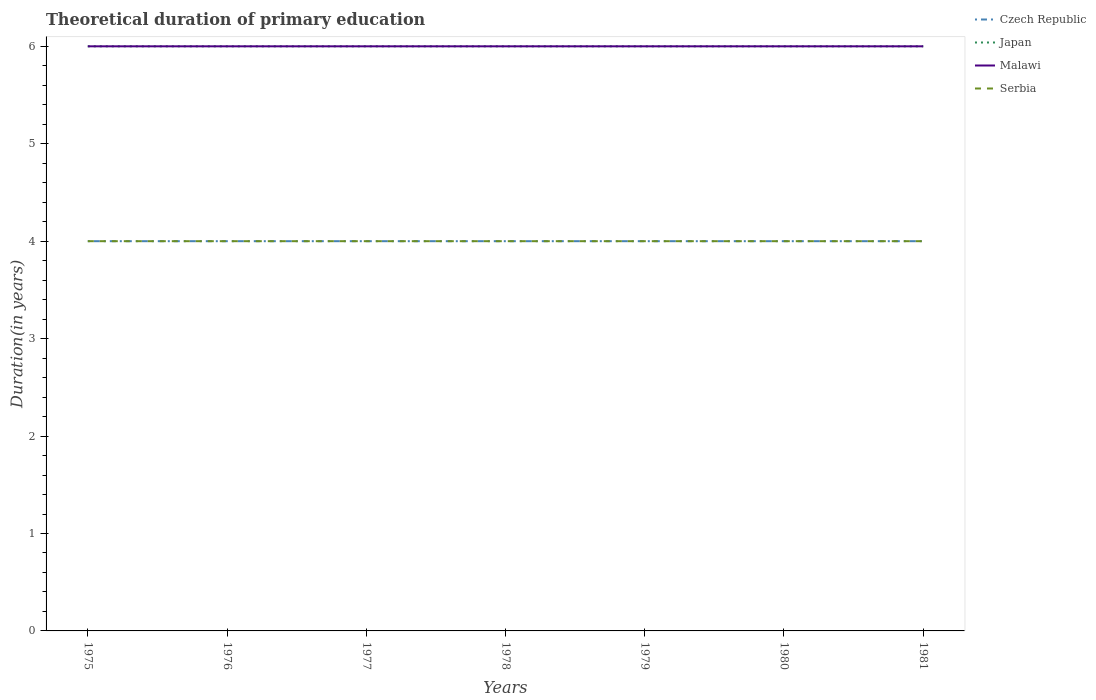Does the line corresponding to Japan intersect with the line corresponding to Malawi?
Offer a very short reply. Yes. Across all years, what is the maximum total theoretical duration of primary education in Czech Republic?
Provide a succinct answer. 4. In which year was the total theoretical duration of primary education in Malawi maximum?
Make the answer very short. 1975. What is the total total theoretical duration of primary education in Serbia in the graph?
Offer a very short reply. 0. Is the total theoretical duration of primary education in Japan strictly greater than the total theoretical duration of primary education in Serbia over the years?
Offer a very short reply. No. How many years are there in the graph?
Make the answer very short. 7. Are the values on the major ticks of Y-axis written in scientific E-notation?
Your answer should be compact. No. Does the graph contain any zero values?
Ensure brevity in your answer.  No. Does the graph contain grids?
Ensure brevity in your answer.  No. What is the title of the graph?
Provide a short and direct response. Theoretical duration of primary education. What is the label or title of the X-axis?
Your response must be concise. Years. What is the label or title of the Y-axis?
Your response must be concise. Duration(in years). What is the Duration(in years) in Malawi in 1975?
Provide a succinct answer. 6. What is the Duration(in years) in Serbia in 1975?
Give a very brief answer. 4. What is the Duration(in years) in Czech Republic in 1977?
Your answer should be very brief. 4. What is the Duration(in years) in Malawi in 1977?
Provide a succinct answer. 6. What is the Duration(in years) of Serbia in 1977?
Your response must be concise. 4. What is the Duration(in years) of Czech Republic in 1978?
Offer a terse response. 4. What is the Duration(in years) in Serbia in 1979?
Give a very brief answer. 4. What is the Duration(in years) in Czech Republic in 1980?
Your answer should be compact. 4. What is the Duration(in years) of Japan in 1980?
Your response must be concise. 6. What is the Duration(in years) of Malawi in 1980?
Provide a short and direct response. 6. What is the Duration(in years) of Czech Republic in 1981?
Your answer should be compact. 4. Across all years, what is the maximum Duration(in years) in Czech Republic?
Your response must be concise. 4. Across all years, what is the maximum Duration(in years) of Japan?
Keep it short and to the point. 6. Across all years, what is the maximum Duration(in years) in Malawi?
Ensure brevity in your answer.  6. Across all years, what is the maximum Duration(in years) of Serbia?
Offer a very short reply. 4. Across all years, what is the minimum Duration(in years) in Czech Republic?
Keep it short and to the point. 4. Across all years, what is the minimum Duration(in years) in Japan?
Your answer should be very brief. 6. What is the total Duration(in years) in Malawi in the graph?
Make the answer very short. 42. What is the difference between the Duration(in years) of Japan in 1975 and that in 1977?
Provide a succinct answer. 0. What is the difference between the Duration(in years) in Malawi in 1975 and that in 1977?
Make the answer very short. 0. What is the difference between the Duration(in years) in Serbia in 1975 and that in 1977?
Keep it short and to the point. 0. What is the difference between the Duration(in years) of Japan in 1975 and that in 1978?
Make the answer very short. 0. What is the difference between the Duration(in years) of Serbia in 1975 and that in 1978?
Your response must be concise. 0. What is the difference between the Duration(in years) of Czech Republic in 1975 and that in 1979?
Your answer should be very brief. 0. What is the difference between the Duration(in years) in Japan in 1975 and that in 1979?
Your answer should be very brief. 0. What is the difference between the Duration(in years) of Malawi in 1975 and that in 1979?
Your answer should be compact. 0. What is the difference between the Duration(in years) in Malawi in 1975 and that in 1980?
Give a very brief answer. 0. What is the difference between the Duration(in years) of Japan in 1975 and that in 1981?
Ensure brevity in your answer.  0. What is the difference between the Duration(in years) in Malawi in 1975 and that in 1981?
Your answer should be very brief. 0. What is the difference between the Duration(in years) in Japan in 1976 and that in 1977?
Ensure brevity in your answer.  0. What is the difference between the Duration(in years) of Malawi in 1976 and that in 1977?
Provide a succinct answer. 0. What is the difference between the Duration(in years) in Serbia in 1976 and that in 1977?
Offer a terse response. 0. What is the difference between the Duration(in years) of Czech Republic in 1976 and that in 1978?
Offer a very short reply. 0. What is the difference between the Duration(in years) of Japan in 1976 and that in 1978?
Your response must be concise. 0. What is the difference between the Duration(in years) of Malawi in 1976 and that in 1978?
Make the answer very short. 0. What is the difference between the Duration(in years) in Czech Republic in 1976 and that in 1979?
Your answer should be compact. 0. What is the difference between the Duration(in years) of Malawi in 1976 and that in 1979?
Keep it short and to the point. 0. What is the difference between the Duration(in years) of Serbia in 1976 and that in 1979?
Give a very brief answer. 0. What is the difference between the Duration(in years) of Serbia in 1976 and that in 1980?
Make the answer very short. 0. What is the difference between the Duration(in years) of Japan in 1976 and that in 1981?
Give a very brief answer. 0. What is the difference between the Duration(in years) of Czech Republic in 1977 and that in 1978?
Your response must be concise. 0. What is the difference between the Duration(in years) in Czech Republic in 1977 and that in 1979?
Provide a succinct answer. 0. What is the difference between the Duration(in years) in Serbia in 1977 and that in 1979?
Provide a short and direct response. 0. What is the difference between the Duration(in years) of Czech Republic in 1977 and that in 1980?
Ensure brevity in your answer.  0. What is the difference between the Duration(in years) in Serbia in 1977 and that in 1980?
Provide a short and direct response. 0. What is the difference between the Duration(in years) in Czech Republic in 1977 and that in 1981?
Provide a short and direct response. 0. What is the difference between the Duration(in years) in Japan in 1977 and that in 1981?
Provide a short and direct response. 0. What is the difference between the Duration(in years) of Malawi in 1977 and that in 1981?
Give a very brief answer. 0. What is the difference between the Duration(in years) of Serbia in 1977 and that in 1981?
Keep it short and to the point. 0. What is the difference between the Duration(in years) in Czech Republic in 1978 and that in 1979?
Make the answer very short. 0. What is the difference between the Duration(in years) in Japan in 1978 and that in 1979?
Keep it short and to the point. 0. What is the difference between the Duration(in years) of Malawi in 1978 and that in 1979?
Your answer should be very brief. 0. What is the difference between the Duration(in years) of Czech Republic in 1978 and that in 1980?
Keep it short and to the point. 0. What is the difference between the Duration(in years) of Malawi in 1978 and that in 1981?
Ensure brevity in your answer.  0. What is the difference between the Duration(in years) in Malawi in 1979 and that in 1980?
Give a very brief answer. 0. What is the difference between the Duration(in years) in Japan in 1979 and that in 1981?
Offer a very short reply. 0. What is the difference between the Duration(in years) in Malawi in 1979 and that in 1981?
Your response must be concise. 0. What is the difference between the Duration(in years) of Serbia in 1979 and that in 1981?
Offer a terse response. 0. What is the difference between the Duration(in years) in Czech Republic in 1980 and that in 1981?
Provide a short and direct response. 0. What is the difference between the Duration(in years) in Japan in 1980 and that in 1981?
Your answer should be compact. 0. What is the difference between the Duration(in years) in Malawi in 1980 and that in 1981?
Give a very brief answer. 0. What is the difference between the Duration(in years) in Serbia in 1980 and that in 1981?
Your answer should be very brief. 0. What is the difference between the Duration(in years) in Czech Republic in 1975 and the Duration(in years) in Serbia in 1976?
Your answer should be compact. 0. What is the difference between the Duration(in years) of Japan in 1975 and the Duration(in years) of Malawi in 1976?
Offer a terse response. 0. What is the difference between the Duration(in years) of Malawi in 1975 and the Duration(in years) of Serbia in 1976?
Your response must be concise. 2. What is the difference between the Duration(in years) of Czech Republic in 1975 and the Duration(in years) of Japan in 1977?
Your answer should be very brief. -2. What is the difference between the Duration(in years) in Japan in 1975 and the Duration(in years) in Malawi in 1977?
Offer a terse response. 0. What is the difference between the Duration(in years) of Japan in 1975 and the Duration(in years) of Serbia in 1977?
Ensure brevity in your answer.  2. What is the difference between the Duration(in years) of Malawi in 1975 and the Duration(in years) of Serbia in 1977?
Your answer should be compact. 2. What is the difference between the Duration(in years) of Czech Republic in 1975 and the Duration(in years) of Japan in 1978?
Keep it short and to the point. -2. What is the difference between the Duration(in years) of Czech Republic in 1975 and the Duration(in years) of Malawi in 1978?
Your response must be concise. -2. What is the difference between the Duration(in years) in Czech Republic in 1975 and the Duration(in years) in Serbia in 1978?
Your answer should be very brief. 0. What is the difference between the Duration(in years) of Czech Republic in 1975 and the Duration(in years) of Malawi in 1979?
Make the answer very short. -2. What is the difference between the Duration(in years) in Czech Republic in 1975 and the Duration(in years) in Serbia in 1979?
Make the answer very short. 0. What is the difference between the Duration(in years) in Japan in 1975 and the Duration(in years) in Malawi in 1979?
Provide a short and direct response. 0. What is the difference between the Duration(in years) of Japan in 1975 and the Duration(in years) of Serbia in 1979?
Your response must be concise. 2. What is the difference between the Duration(in years) in Malawi in 1975 and the Duration(in years) in Serbia in 1979?
Your answer should be very brief. 2. What is the difference between the Duration(in years) of Czech Republic in 1975 and the Duration(in years) of Japan in 1980?
Offer a very short reply. -2. What is the difference between the Duration(in years) in Czech Republic in 1975 and the Duration(in years) in Malawi in 1980?
Offer a very short reply. -2. What is the difference between the Duration(in years) of Japan in 1975 and the Duration(in years) of Malawi in 1980?
Offer a very short reply. 0. What is the difference between the Duration(in years) of Japan in 1975 and the Duration(in years) of Serbia in 1980?
Your answer should be compact. 2. What is the difference between the Duration(in years) in Malawi in 1975 and the Duration(in years) in Serbia in 1980?
Your response must be concise. 2. What is the difference between the Duration(in years) of Czech Republic in 1975 and the Duration(in years) of Malawi in 1981?
Keep it short and to the point. -2. What is the difference between the Duration(in years) in Japan in 1976 and the Duration(in years) in Serbia in 1977?
Ensure brevity in your answer.  2. What is the difference between the Duration(in years) of Malawi in 1976 and the Duration(in years) of Serbia in 1977?
Offer a terse response. 2. What is the difference between the Duration(in years) of Czech Republic in 1976 and the Duration(in years) of Japan in 1978?
Provide a short and direct response. -2. What is the difference between the Duration(in years) of Japan in 1976 and the Duration(in years) of Malawi in 1978?
Provide a short and direct response. 0. What is the difference between the Duration(in years) of Japan in 1976 and the Duration(in years) of Serbia in 1978?
Your answer should be very brief. 2. What is the difference between the Duration(in years) of Czech Republic in 1976 and the Duration(in years) of Japan in 1979?
Keep it short and to the point. -2. What is the difference between the Duration(in years) in Japan in 1976 and the Duration(in years) in Malawi in 1979?
Ensure brevity in your answer.  0. What is the difference between the Duration(in years) in Japan in 1976 and the Duration(in years) in Serbia in 1979?
Your answer should be very brief. 2. What is the difference between the Duration(in years) of Czech Republic in 1976 and the Duration(in years) of Malawi in 1980?
Ensure brevity in your answer.  -2. What is the difference between the Duration(in years) in Czech Republic in 1976 and the Duration(in years) in Serbia in 1980?
Keep it short and to the point. 0. What is the difference between the Duration(in years) in Japan in 1976 and the Duration(in years) in Malawi in 1980?
Give a very brief answer. 0. What is the difference between the Duration(in years) of Czech Republic in 1976 and the Duration(in years) of Japan in 1981?
Offer a very short reply. -2. What is the difference between the Duration(in years) in Japan in 1976 and the Duration(in years) in Malawi in 1981?
Your answer should be very brief. 0. What is the difference between the Duration(in years) of Malawi in 1976 and the Duration(in years) of Serbia in 1981?
Your answer should be very brief. 2. What is the difference between the Duration(in years) in Czech Republic in 1977 and the Duration(in years) in Japan in 1978?
Your answer should be compact. -2. What is the difference between the Duration(in years) of Czech Republic in 1977 and the Duration(in years) of Serbia in 1978?
Your answer should be very brief. 0. What is the difference between the Duration(in years) of Czech Republic in 1977 and the Duration(in years) of Malawi in 1979?
Your answer should be very brief. -2. What is the difference between the Duration(in years) of Czech Republic in 1977 and the Duration(in years) of Serbia in 1979?
Your answer should be very brief. 0. What is the difference between the Duration(in years) in Czech Republic in 1977 and the Duration(in years) in Japan in 1980?
Make the answer very short. -2. What is the difference between the Duration(in years) in Czech Republic in 1977 and the Duration(in years) in Malawi in 1980?
Offer a terse response. -2. What is the difference between the Duration(in years) of Malawi in 1977 and the Duration(in years) of Serbia in 1980?
Keep it short and to the point. 2. What is the difference between the Duration(in years) in Czech Republic in 1977 and the Duration(in years) in Malawi in 1981?
Offer a terse response. -2. What is the difference between the Duration(in years) of Czech Republic in 1977 and the Duration(in years) of Serbia in 1981?
Give a very brief answer. 0. What is the difference between the Duration(in years) in Japan in 1977 and the Duration(in years) in Serbia in 1981?
Offer a very short reply. 2. What is the difference between the Duration(in years) of Czech Republic in 1978 and the Duration(in years) of Japan in 1979?
Your answer should be very brief. -2. What is the difference between the Duration(in years) in Malawi in 1978 and the Duration(in years) in Serbia in 1979?
Your response must be concise. 2. What is the difference between the Duration(in years) in Japan in 1978 and the Duration(in years) in Malawi in 1980?
Your answer should be very brief. 0. What is the difference between the Duration(in years) of Malawi in 1978 and the Duration(in years) of Serbia in 1980?
Your response must be concise. 2. What is the difference between the Duration(in years) of Czech Republic in 1978 and the Duration(in years) of Japan in 1981?
Provide a short and direct response. -2. What is the difference between the Duration(in years) of Czech Republic in 1979 and the Duration(in years) of Malawi in 1980?
Provide a succinct answer. -2. What is the difference between the Duration(in years) of Czech Republic in 1979 and the Duration(in years) of Serbia in 1980?
Make the answer very short. 0. What is the difference between the Duration(in years) of Japan in 1979 and the Duration(in years) of Malawi in 1980?
Keep it short and to the point. 0. What is the difference between the Duration(in years) in Czech Republic in 1979 and the Duration(in years) in Japan in 1981?
Your answer should be very brief. -2. What is the difference between the Duration(in years) in Czech Republic in 1979 and the Duration(in years) in Serbia in 1981?
Provide a succinct answer. 0. What is the difference between the Duration(in years) of Japan in 1979 and the Duration(in years) of Serbia in 1981?
Ensure brevity in your answer.  2. What is the difference between the Duration(in years) in Malawi in 1979 and the Duration(in years) in Serbia in 1981?
Offer a terse response. 2. What is the difference between the Duration(in years) of Japan in 1980 and the Duration(in years) of Malawi in 1981?
Keep it short and to the point. 0. What is the average Duration(in years) of Japan per year?
Make the answer very short. 6. What is the average Duration(in years) in Malawi per year?
Your response must be concise. 6. In the year 1975, what is the difference between the Duration(in years) of Czech Republic and Duration(in years) of Japan?
Ensure brevity in your answer.  -2. In the year 1975, what is the difference between the Duration(in years) in Czech Republic and Duration(in years) in Malawi?
Your answer should be very brief. -2. In the year 1975, what is the difference between the Duration(in years) in Japan and Duration(in years) in Malawi?
Give a very brief answer. 0. In the year 1975, what is the difference between the Duration(in years) in Japan and Duration(in years) in Serbia?
Provide a succinct answer. 2. In the year 1976, what is the difference between the Duration(in years) of Czech Republic and Duration(in years) of Japan?
Give a very brief answer. -2. In the year 1976, what is the difference between the Duration(in years) in Japan and Duration(in years) in Serbia?
Your response must be concise. 2. In the year 1977, what is the difference between the Duration(in years) of Czech Republic and Duration(in years) of Japan?
Offer a terse response. -2. In the year 1977, what is the difference between the Duration(in years) of Czech Republic and Duration(in years) of Malawi?
Offer a very short reply. -2. In the year 1977, what is the difference between the Duration(in years) in Czech Republic and Duration(in years) in Serbia?
Your answer should be compact. 0. In the year 1978, what is the difference between the Duration(in years) of Czech Republic and Duration(in years) of Japan?
Offer a very short reply. -2. In the year 1978, what is the difference between the Duration(in years) of Czech Republic and Duration(in years) of Malawi?
Offer a very short reply. -2. In the year 1978, what is the difference between the Duration(in years) in Japan and Duration(in years) in Serbia?
Keep it short and to the point. 2. In the year 1978, what is the difference between the Duration(in years) of Malawi and Duration(in years) of Serbia?
Offer a very short reply. 2. In the year 1979, what is the difference between the Duration(in years) of Czech Republic and Duration(in years) of Japan?
Give a very brief answer. -2. In the year 1979, what is the difference between the Duration(in years) of Japan and Duration(in years) of Serbia?
Ensure brevity in your answer.  2. In the year 1980, what is the difference between the Duration(in years) in Czech Republic and Duration(in years) in Serbia?
Your answer should be compact. 0. In the year 1980, what is the difference between the Duration(in years) in Malawi and Duration(in years) in Serbia?
Your answer should be compact. 2. In the year 1981, what is the difference between the Duration(in years) in Japan and Duration(in years) in Malawi?
Provide a succinct answer. 0. In the year 1981, what is the difference between the Duration(in years) in Malawi and Duration(in years) in Serbia?
Keep it short and to the point. 2. What is the ratio of the Duration(in years) of Malawi in 1975 to that in 1976?
Provide a short and direct response. 1. What is the ratio of the Duration(in years) of Serbia in 1975 to that in 1976?
Ensure brevity in your answer.  1. What is the ratio of the Duration(in years) in Malawi in 1975 to that in 1977?
Provide a short and direct response. 1. What is the ratio of the Duration(in years) in Japan in 1975 to that in 1978?
Make the answer very short. 1. What is the ratio of the Duration(in years) in Malawi in 1975 to that in 1978?
Your answer should be compact. 1. What is the ratio of the Duration(in years) in Japan in 1975 to that in 1980?
Your response must be concise. 1. What is the ratio of the Duration(in years) of Malawi in 1975 to that in 1980?
Your answer should be compact. 1. What is the ratio of the Duration(in years) of Czech Republic in 1976 to that in 1977?
Give a very brief answer. 1. What is the ratio of the Duration(in years) in Malawi in 1976 to that in 1977?
Your response must be concise. 1. What is the ratio of the Duration(in years) in Czech Republic in 1976 to that in 1978?
Give a very brief answer. 1. What is the ratio of the Duration(in years) in Japan in 1976 to that in 1978?
Your response must be concise. 1. What is the ratio of the Duration(in years) in Malawi in 1976 to that in 1978?
Provide a succinct answer. 1. What is the ratio of the Duration(in years) in Serbia in 1976 to that in 1978?
Offer a very short reply. 1. What is the ratio of the Duration(in years) in Czech Republic in 1976 to that in 1979?
Offer a terse response. 1. What is the ratio of the Duration(in years) in Japan in 1976 to that in 1979?
Ensure brevity in your answer.  1. What is the ratio of the Duration(in years) in Malawi in 1976 to that in 1979?
Keep it short and to the point. 1. What is the ratio of the Duration(in years) in Serbia in 1976 to that in 1979?
Keep it short and to the point. 1. What is the ratio of the Duration(in years) of Japan in 1976 to that in 1980?
Your answer should be very brief. 1. What is the ratio of the Duration(in years) of Serbia in 1976 to that in 1980?
Ensure brevity in your answer.  1. What is the ratio of the Duration(in years) in Czech Republic in 1976 to that in 1981?
Offer a very short reply. 1. What is the ratio of the Duration(in years) of Malawi in 1976 to that in 1981?
Your response must be concise. 1. What is the ratio of the Duration(in years) in Serbia in 1976 to that in 1981?
Your answer should be compact. 1. What is the ratio of the Duration(in years) of Serbia in 1977 to that in 1978?
Your response must be concise. 1. What is the ratio of the Duration(in years) in Czech Republic in 1977 to that in 1979?
Provide a short and direct response. 1. What is the ratio of the Duration(in years) of Malawi in 1977 to that in 1979?
Give a very brief answer. 1. What is the ratio of the Duration(in years) of Czech Republic in 1977 to that in 1981?
Provide a succinct answer. 1. What is the ratio of the Duration(in years) of Japan in 1977 to that in 1981?
Provide a succinct answer. 1. What is the ratio of the Duration(in years) in Czech Republic in 1978 to that in 1979?
Your response must be concise. 1. What is the ratio of the Duration(in years) of Japan in 1978 to that in 1979?
Provide a short and direct response. 1. What is the ratio of the Duration(in years) of Serbia in 1978 to that in 1979?
Make the answer very short. 1. What is the ratio of the Duration(in years) of Czech Republic in 1978 to that in 1980?
Your response must be concise. 1. What is the ratio of the Duration(in years) of Japan in 1978 to that in 1980?
Your answer should be very brief. 1. What is the ratio of the Duration(in years) in Czech Republic in 1978 to that in 1981?
Provide a short and direct response. 1. What is the ratio of the Duration(in years) in Malawi in 1978 to that in 1981?
Your answer should be compact. 1. What is the ratio of the Duration(in years) of Czech Republic in 1979 to that in 1980?
Keep it short and to the point. 1. What is the ratio of the Duration(in years) of Malawi in 1979 to that in 1980?
Offer a very short reply. 1. What is the ratio of the Duration(in years) in Japan in 1979 to that in 1981?
Keep it short and to the point. 1. What is the ratio of the Duration(in years) in Malawi in 1979 to that in 1981?
Provide a succinct answer. 1. What is the ratio of the Duration(in years) in Serbia in 1979 to that in 1981?
Offer a terse response. 1. What is the ratio of the Duration(in years) in Japan in 1980 to that in 1981?
Make the answer very short. 1. What is the ratio of the Duration(in years) in Malawi in 1980 to that in 1981?
Your response must be concise. 1. What is the difference between the highest and the second highest Duration(in years) in Czech Republic?
Give a very brief answer. 0. What is the difference between the highest and the second highest Duration(in years) of Japan?
Make the answer very short. 0. What is the difference between the highest and the second highest Duration(in years) in Serbia?
Offer a terse response. 0. What is the difference between the highest and the lowest Duration(in years) in Japan?
Keep it short and to the point. 0. What is the difference between the highest and the lowest Duration(in years) in Malawi?
Offer a terse response. 0. What is the difference between the highest and the lowest Duration(in years) in Serbia?
Provide a short and direct response. 0. 